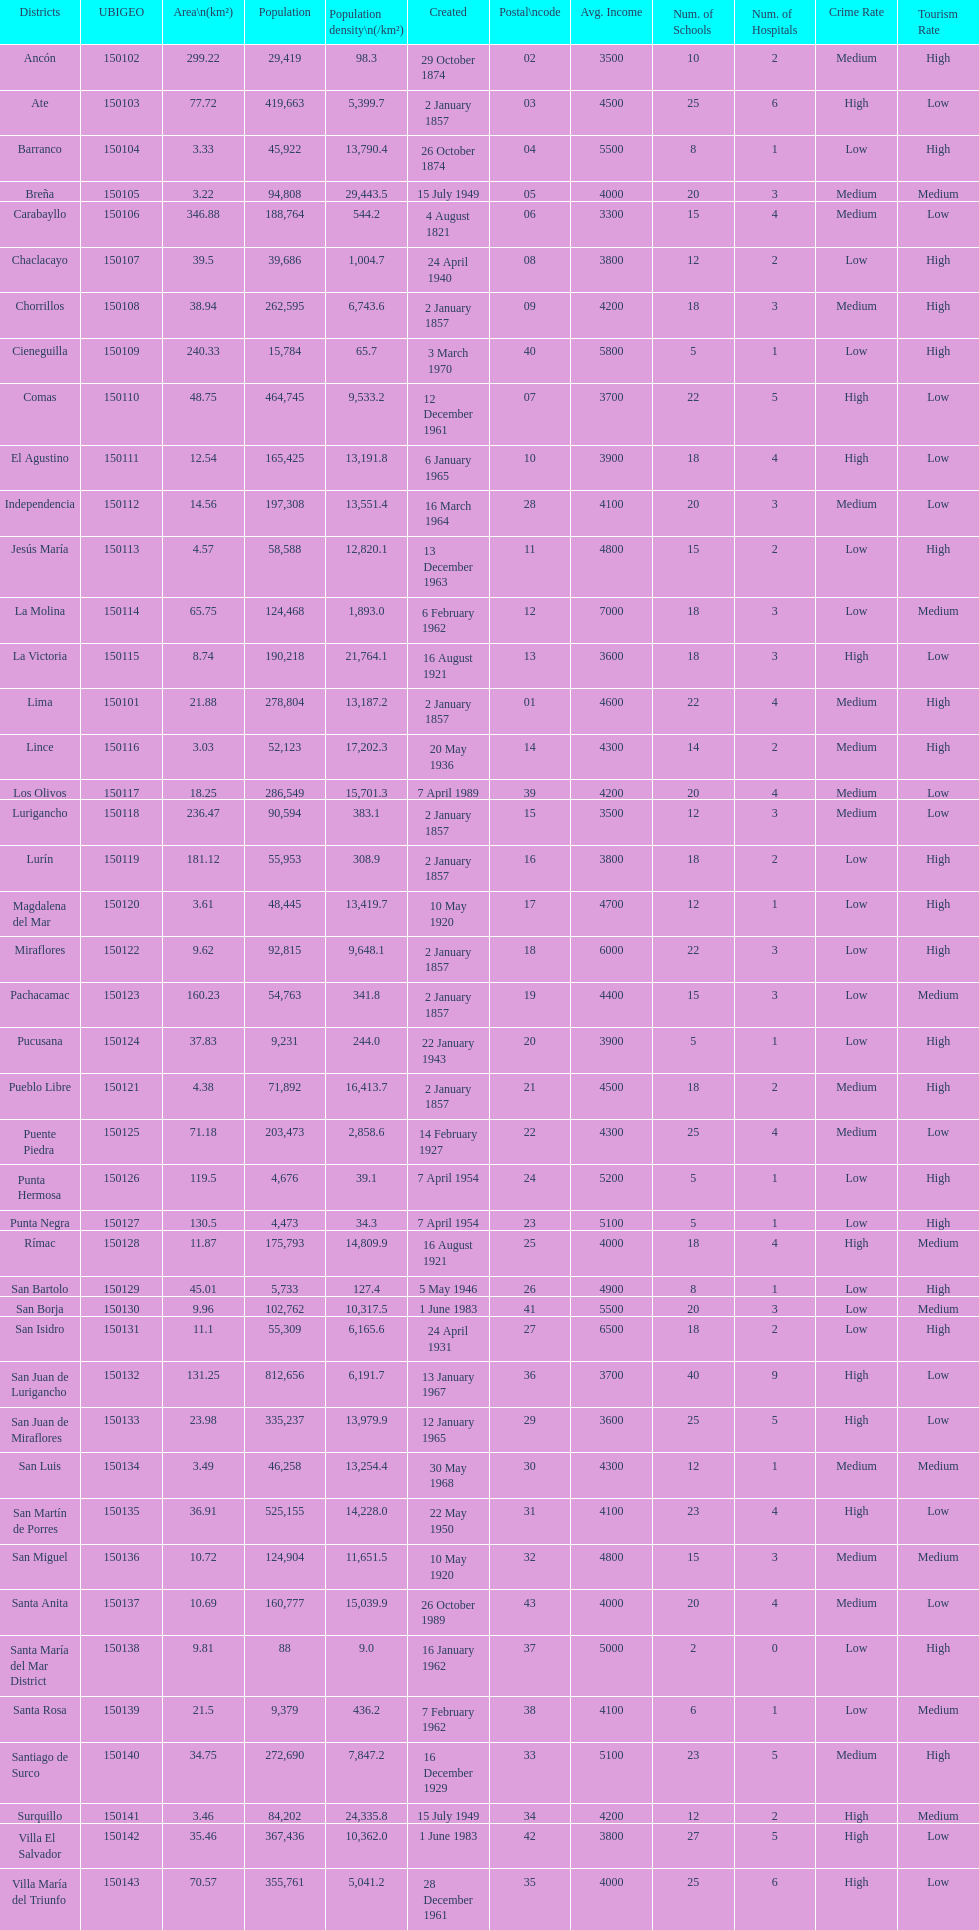Which district in this city has the greatest population? San Juan de Lurigancho. 